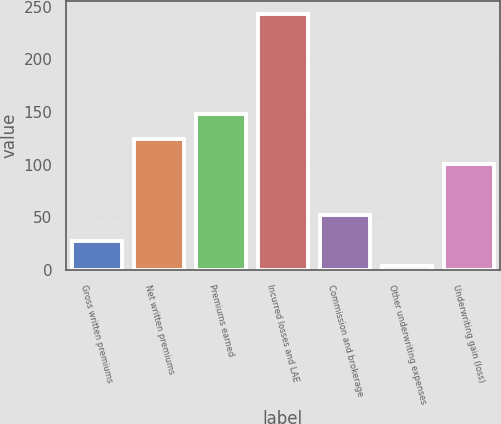<chart> <loc_0><loc_0><loc_500><loc_500><bar_chart><fcel>Gross written premiums<fcel>Net written premiums<fcel>Premiums earned<fcel>Incurred losses and LAE<fcel>Commission and brokerage<fcel>Other underwriting expenses<fcel>Underwriting gain (loss)<nl><fcel>27.94<fcel>124.54<fcel>148.48<fcel>243.4<fcel>51.88<fcel>4<fcel>100.6<nl></chart> 